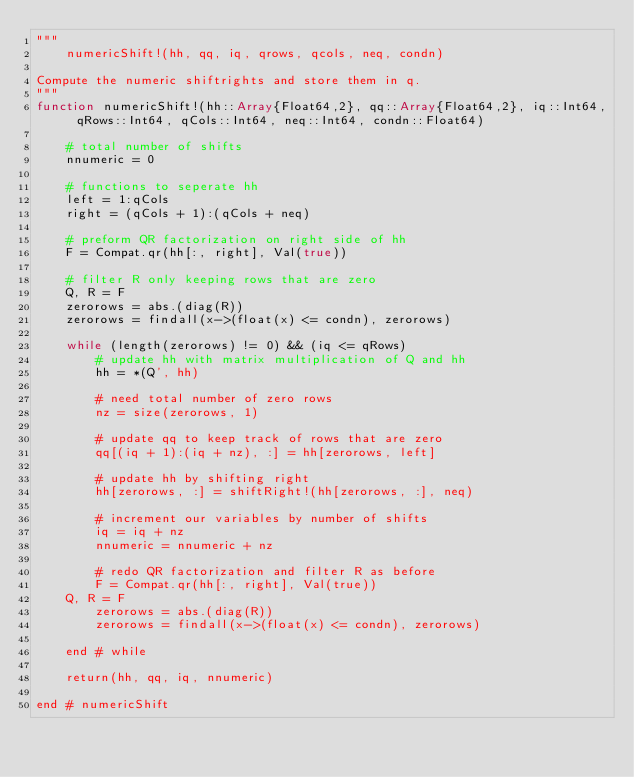Convert code to text. <code><loc_0><loc_0><loc_500><loc_500><_Julia_>"""
    numericShift!(hh, qq, iq, qrows, qcols, neq, condn)

Compute the numeric shiftrights and store them in q.
"""
function numericShift!(hh::Array{Float64,2}, qq::Array{Float64,2}, iq::Int64, qRows::Int64, qCols::Int64, neq::Int64, condn::Float64) 

    # total number of shifts
    nnumeric = 0
    
    # functions to seperate hh
    left = 1:qCols
    right = (qCols + 1):(qCols + neq)

    # preform QR factorization on right side of hh
    F = Compat.qr(hh[:, right], Val(true))

    # filter R only keeping rows that are zero
    Q, R = F
    zerorows = abs.(diag(R))
    zerorows = findall(x->(float(x) <= condn), zerorows)

    while (length(zerorows) != 0) && (iq <= qRows)
        # update hh with matrix multiplication of Q and hh
        hh = *(Q', hh)

        # need total number of zero rows
        nz = size(zerorows, 1)

        # update qq to keep track of rows that are zero
        qq[(iq + 1):(iq + nz), :] = hh[zerorows, left]

        # update hh by shifting right
        hh[zerorows, :] = shiftRight!(hh[zerorows, :], neq)

        # increment our variables by number of shifts
        iq = iq + nz
        nnumeric = nnumeric + nz

        # redo QR factorization and filter R as before
        F = Compat.qr(hh[:, right], Val(true))
	Q, R = F
        zerorows = abs.(diag(R))
        zerorows = findall(x->(float(x) <= condn), zerorows)

    end # while
    
    return(hh, qq, iq, nnumeric)

end # numericShift
</code> 